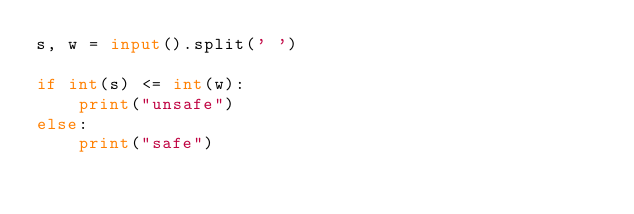<code> <loc_0><loc_0><loc_500><loc_500><_Python_>s, w = input().split(' ')

if int(s) <= int(w):
    print("unsafe")
else:
    print("safe")</code> 